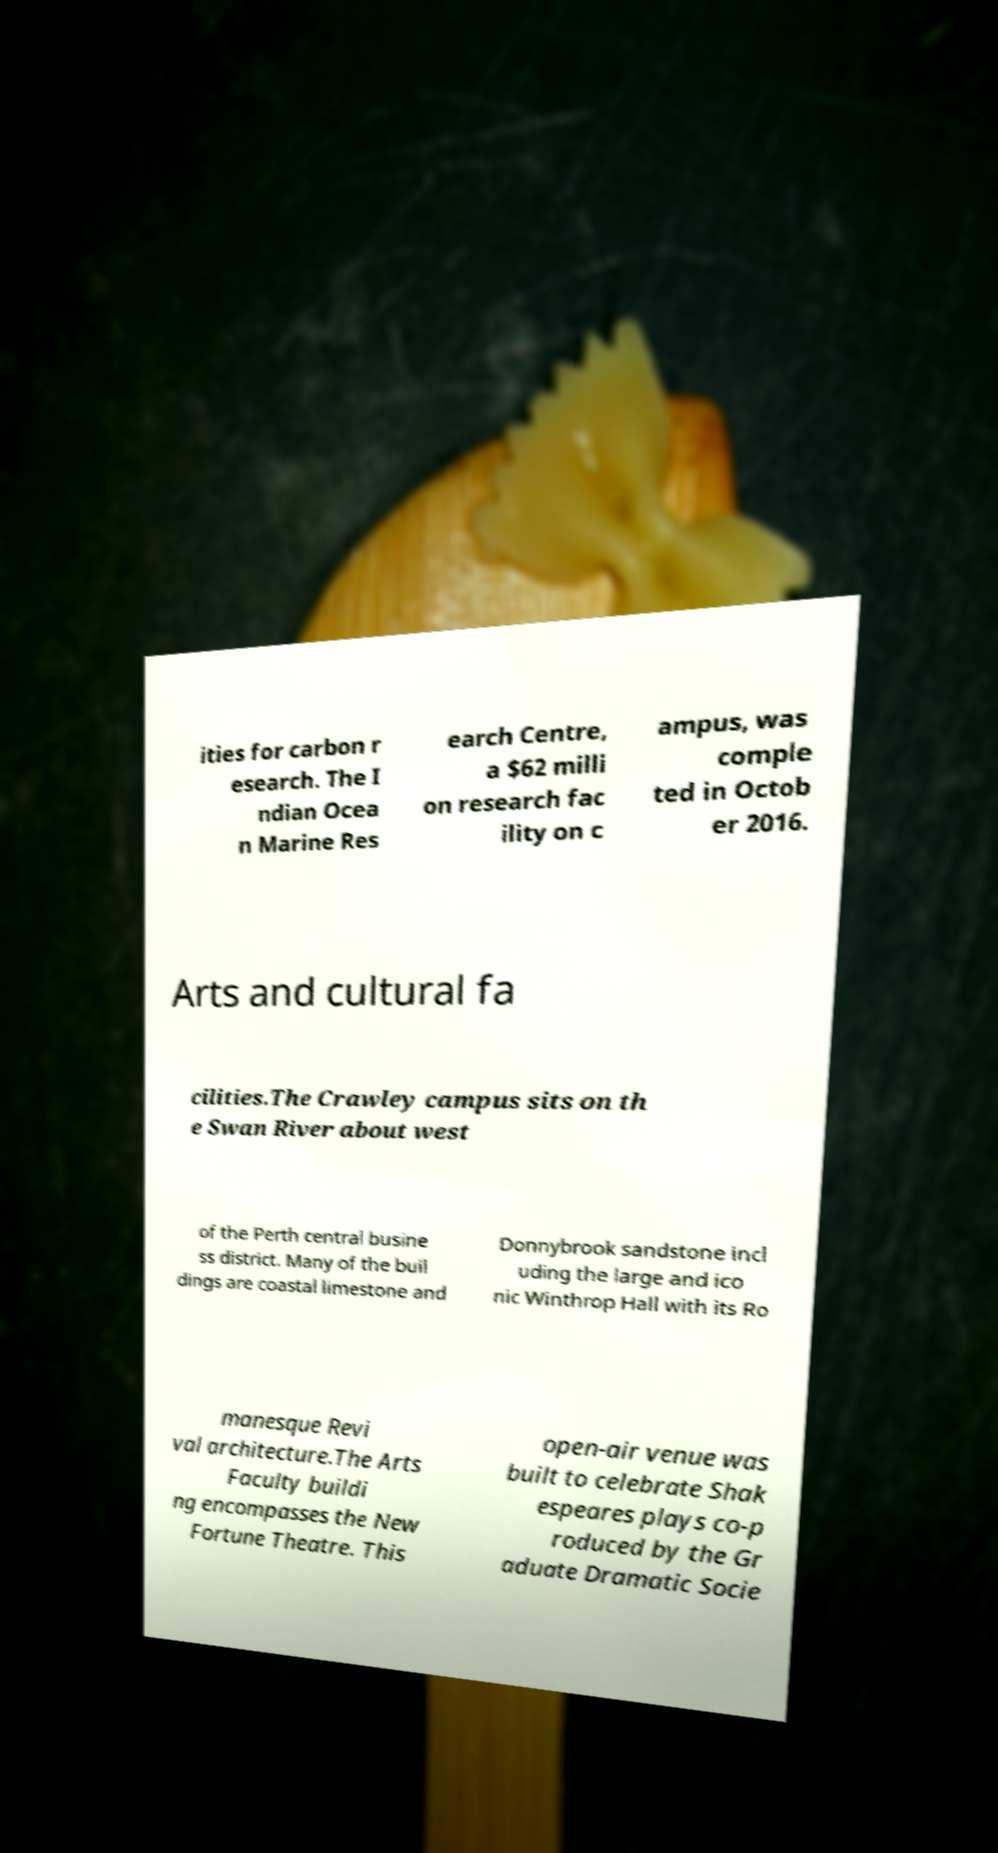Please identify and transcribe the text found in this image. ities for carbon r esearch. The I ndian Ocea n Marine Res earch Centre, a $62 milli on research fac ility on c ampus, was comple ted in Octob er 2016. Arts and cultural fa cilities.The Crawley campus sits on th e Swan River about west of the Perth central busine ss district. Many of the buil dings are coastal limestone and Donnybrook sandstone incl uding the large and ico nic Winthrop Hall with its Ro manesque Revi val architecture.The Arts Faculty buildi ng encompasses the New Fortune Theatre. This open-air venue was built to celebrate Shak espeares plays co-p roduced by the Gr aduate Dramatic Socie 